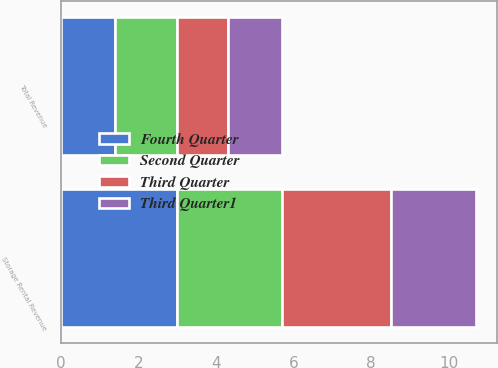Convert chart. <chart><loc_0><loc_0><loc_500><loc_500><stacked_bar_chart><ecel><fcel>Storage Rental Revenue<fcel>Total Revenue<nl><fcel>Fourth Quarter<fcel>3<fcel>1.4<nl><fcel>Second Quarter<fcel>2.7<fcel>1.6<nl><fcel>Third Quarter<fcel>2.8<fcel>1.3<nl><fcel>Third Quarter1<fcel>2.2<fcel>1.4<nl></chart> 